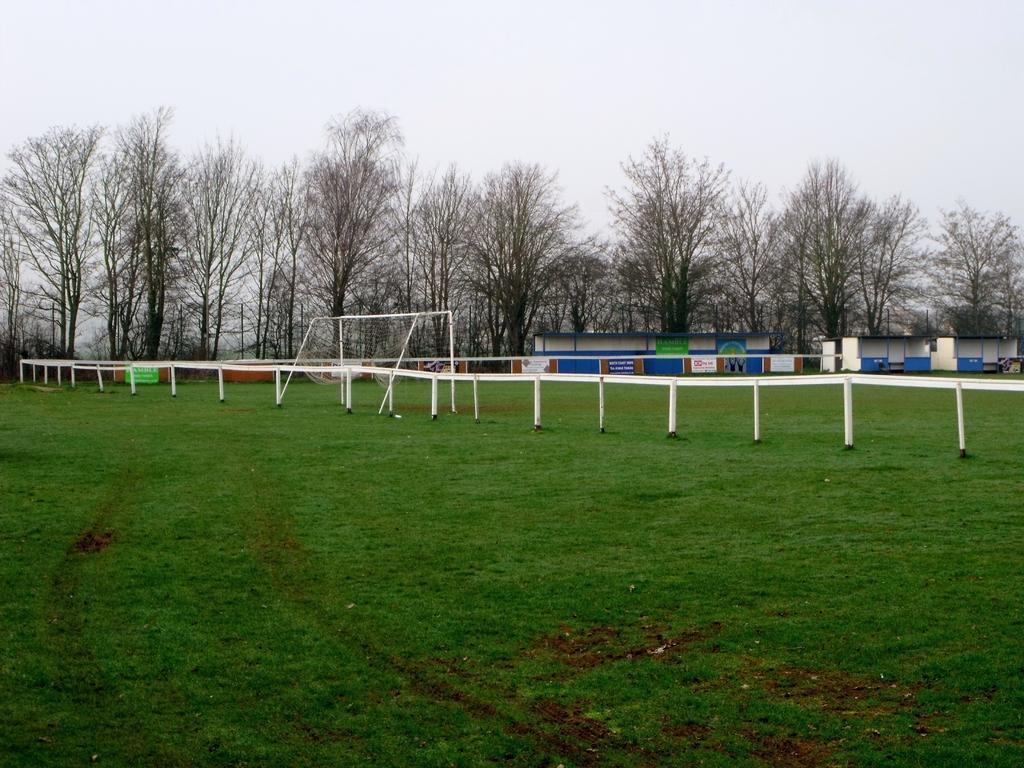Could you give a brief overview of what you see in this image? In this image, we can see grass, rods, net, banners, sheds and trees. Background there is the sky. 